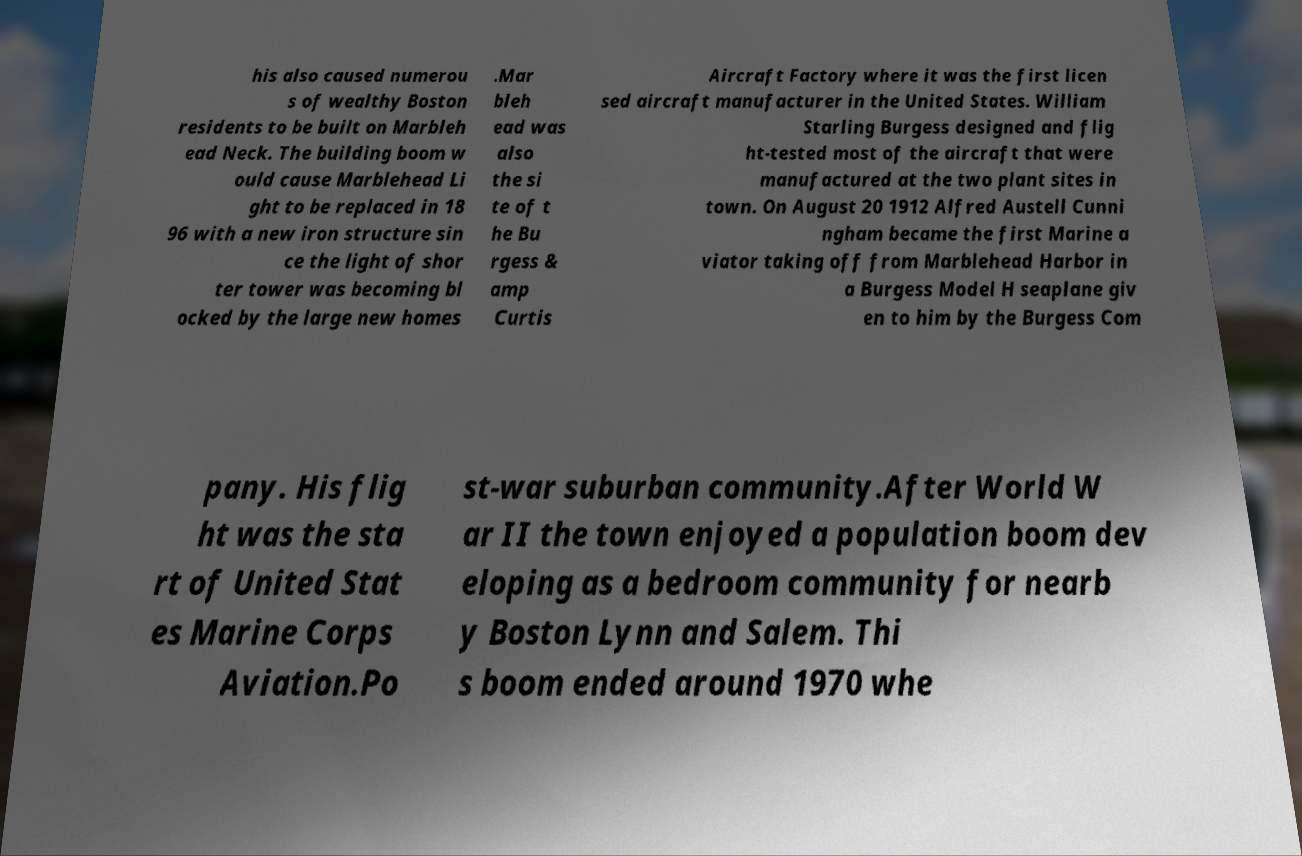Please read and relay the text visible in this image. What does it say? his also caused numerou s of wealthy Boston residents to be built on Marbleh ead Neck. The building boom w ould cause Marblehead Li ght to be replaced in 18 96 with a new iron structure sin ce the light of shor ter tower was becoming bl ocked by the large new homes .Mar bleh ead was also the si te of t he Bu rgess & amp Curtis Aircraft Factory where it was the first licen sed aircraft manufacturer in the United States. William Starling Burgess designed and flig ht-tested most of the aircraft that were manufactured at the two plant sites in town. On August 20 1912 Alfred Austell Cunni ngham became the first Marine a viator taking off from Marblehead Harbor in a Burgess Model H seaplane giv en to him by the Burgess Com pany. His flig ht was the sta rt of United Stat es Marine Corps Aviation.Po st-war suburban community.After World W ar II the town enjoyed a population boom dev eloping as a bedroom community for nearb y Boston Lynn and Salem. Thi s boom ended around 1970 whe 